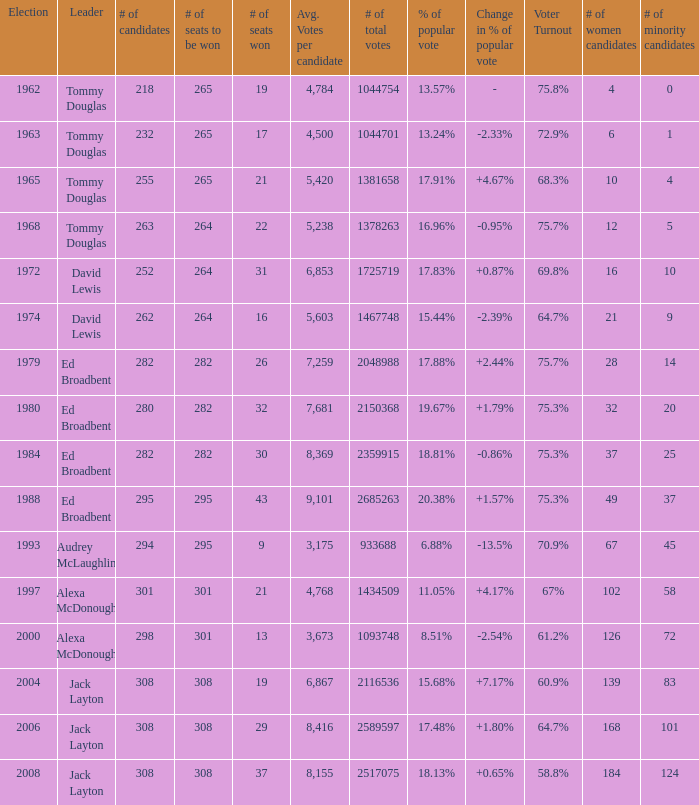Name the number of total votes for # of seats won being 30 2359915.0. 